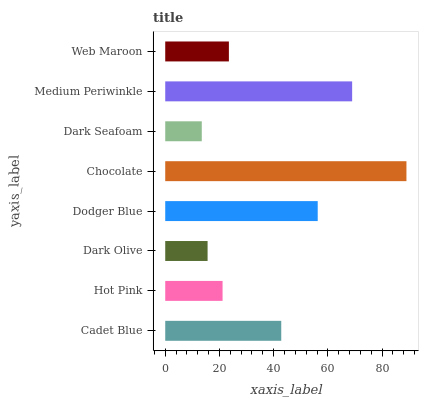Is Dark Seafoam the minimum?
Answer yes or no. Yes. Is Chocolate the maximum?
Answer yes or no. Yes. Is Hot Pink the minimum?
Answer yes or no. No. Is Hot Pink the maximum?
Answer yes or no. No. Is Cadet Blue greater than Hot Pink?
Answer yes or no. Yes. Is Hot Pink less than Cadet Blue?
Answer yes or no. Yes. Is Hot Pink greater than Cadet Blue?
Answer yes or no. No. Is Cadet Blue less than Hot Pink?
Answer yes or no. No. Is Cadet Blue the high median?
Answer yes or no. Yes. Is Web Maroon the low median?
Answer yes or no. Yes. Is Dark Seafoam the high median?
Answer yes or no. No. Is Chocolate the low median?
Answer yes or no. No. 